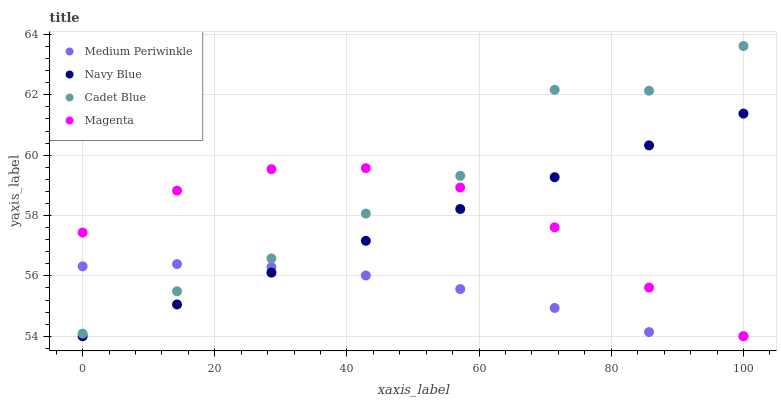Does Medium Periwinkle have the minimum area under the curve?
Answer yes or no. Yes. Does Cadet Blue have the maximum area under the curve?
Answer yes or no. Yes. Does Magenta have the minimum area under the curve?
Answer yes or no. No. Does Magenta have the maximum area under the curve?
Answer yes or no. No. Is Navy Blue the smoothest?
Answer yes or no. Yes. Is Cadet Blue the roughest?
Answer yes or no. Yes. Is Magenta the smoothest?
Answer yes or no. No. Is Magenta the roughest?
Answer yes or no. No. Does Navy Blue have the lowest value?
Answer yes or no. Yes. Does Cadet Blue have the lowest value?
Answer yes or no. No. Does Cadet Blue have the highest value?
Answer yes or no. Yes. Does Magenta have the highest value?
Answer yes or no. No. Is Navy Blue less than Cadet Blue?
Answer yes or no. Yes. Is Cadet Blue greater than Navy Blue?
Answer yes or no. Yes. Does Magenta intersect Medium Periwinkle?
Answer yes or no. Yes. Is Magenta less than Medium Periwinkle?
Answer yes or no. No. Is Magenta greater than Medium Periwinkle?
Answer yes or no. No. Does Navy Blue intersect Cadet Blue?
Answer yes or no. No. 